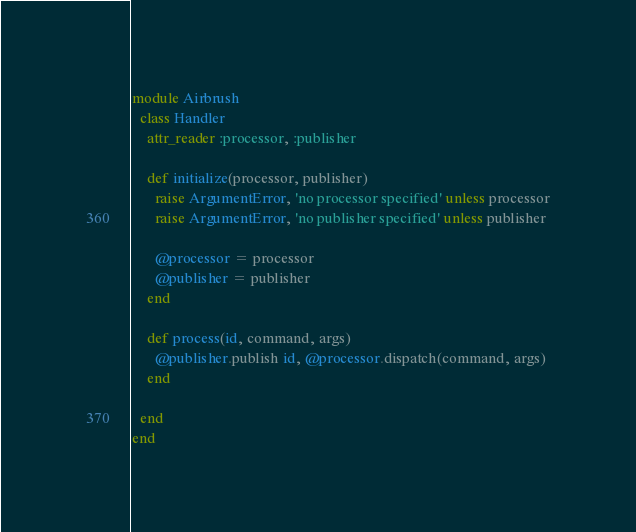<code> <loc_0><loc_0><loc_500><loc_500><_Ruby_>module Airbrush  
  class Handler
    attr_reader :processor, :publisher
    
    def initialize(processor, publisher)
      raise ArgumentError, 'no processor specified' unless processor
      raise ArgumentError, 'no publisher specified' unless publisher
      
      @processor = processor
      @publisher = publisher
    end

    def process(id, command, args)
      @publisher.publish id, @processor.dispatch(command, args)
    end

  end
end
</code> 